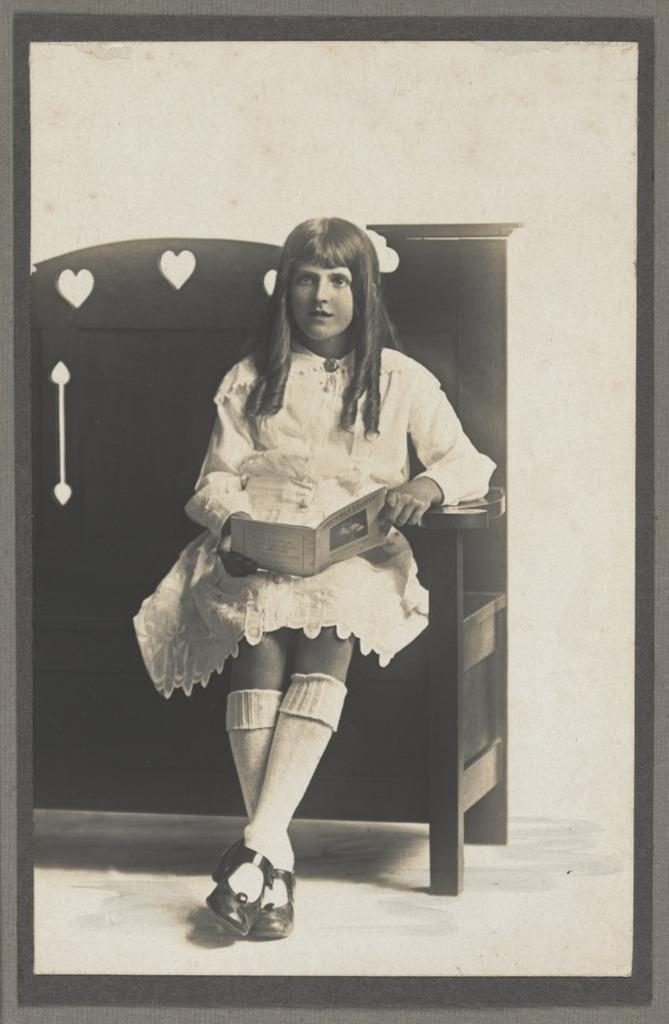What object can be seen in the image that typically holds a picture? There is a picture frame in the image. What is the girl in the image doing? The girl is sitting on a bench in the image. What is the girl holding in her hand? The girl is holding a book in her hand. What can be seen behind the girl in the image? There is a wall in the background of the image. How many centimeters is the girl's knee bent in the image? The image does not provide information about the angle of the girl's knee, so it cannot be determined. 